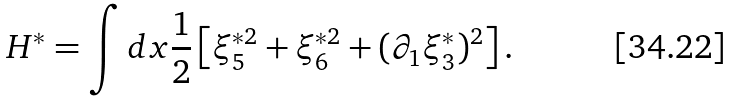<formula> <loc_0><loc_0><loc_500><loc_500>H ^ { \ast } = \int d x \frac { 1 } { 2 } \left [ \xi _ { 5 } ^ { \ast 2 } + \xi _ { 6 } ^ { \ast 2 } + ( \partial _ { 1 } \xi _ { 3 } ^ { \ast } ) ^ { 2 } \right ] .</formula> 